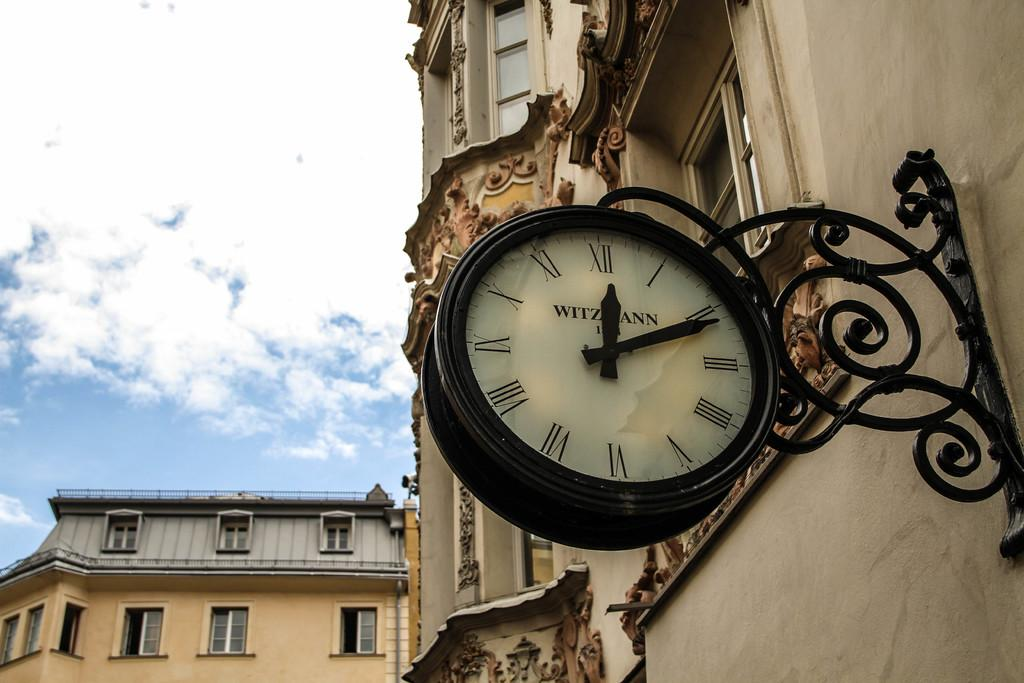<image>
Share a concise interpretation of the image provided. Clock hanging on a building with the word WITZMANN on the face. 